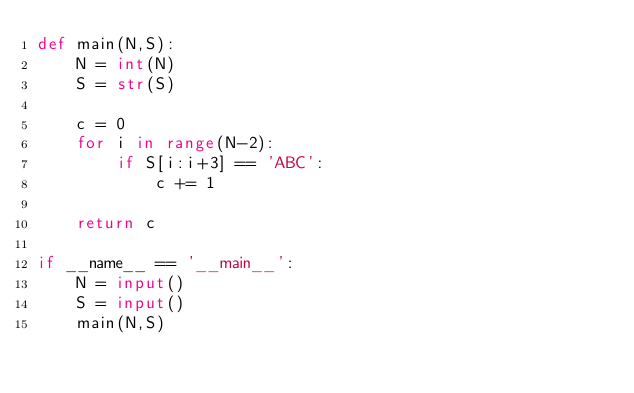<code> <loc_0><loc_0><loc_500><loc_500><_Python_>def main(N,S):
    N = int(N)
    S = str(S)

    c = 0
    for i in range(N-2):
        if S[i:i+3] == 'ABC':
            c += 1

    return c

if __name__ == '__main__':
    N = input()
    S = input()
    main(N,S)
</code> 